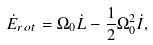Convert formula to latex. <formula><loc_0><loc_0><loc_500><loc_500>\dot { E } _ { r o t } = \Omega _ { 0 } \dot { L } - \frac { 1 } { 2 } \Omega _ { 0 } ^ { 2 } \dot { I } ,</formula> 